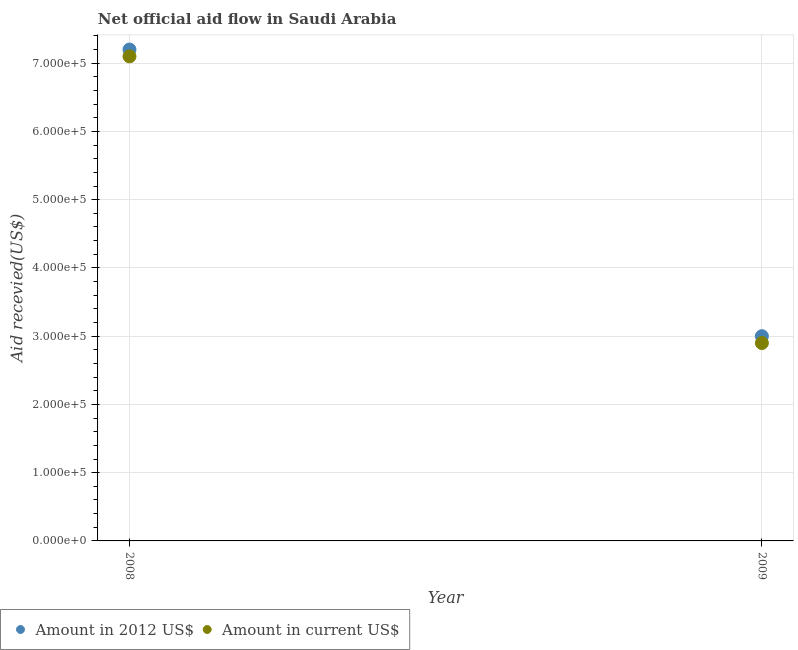Is the number of dotlines equal to the number of legend labels?
Your response must be concise. Yes. What is the amount of aid received(expressed in 2012 us$) in 2008?
Your response must be concise. 7.20e+05. Across all years, what is the maximum amount of aid received(expressed in 2012 us$)?
Ensure brevity in your answer.  7.20e+05. Across all years, what is the minimum amount of aid received(expressed in us$)?
Your response must be concise. 2.90e+05. In which year was the amount of aid received(expressed in 2012 us$) maximum?
Your response must be concise. 2008. In which year was the amount of aid received(expressed in us$) minimum?
Make the answer very short. 2009. What is the total amount of aid received(expressed in us$) in the graph?
Keep it short and to the point. 1.00e+06. What is the difference between the amount of aid received(expressed in 2012 us$) in 2008 and that in 2009?
Your response must be concise. 4.20e+05. What is the difference between the amount of aid received(expressed in us$) in 2008 and the amount of aid received(expressed in 2012 us$) in 2009?
Keep it short and to the point. 4.10e+05. What is the average amount of aid received(expressed in 2012 us$) per year?
Your answer should be very brief. 5.10e+05. In the year 2008, what is the difference between the amount of aid received(expressed in us$) and amount of aid received(expressed in 2012 us$)?
Your answer should be very brief. -10000. In how many years, is the amount of aid received(expressed in us$) greater than 600000 US$?
Provide a short and direct response. 1. Is the amount of aid received(expressed in 2012 us$) strictly less than the amount of aid received(expressed in us$) over the years?
Provide a short and direct response. No. How many dotlines are there?
Offer a very short reply. 2. Does the graph contain any zero values?
Keep it short and to the point. No. How many legend labels are there?
Provide a succinct answer. 2. What is the title of the graph?
Your answer should be very brief. Net official aid flow in Saudi Arabia. Does "Unregistered firms" appear as one of the legend labels in the graph?
Offer a very short reply. No. What is the label or title of the X-axis?
Ensure brevity in your answer.  Year. What is the label or title of the Y-axis?
Provide a short and direct response. Aid recevied(US$). What is the Aid recevied(US$) of Amount in 2012 US$ in 2008?
Offer a very short reply. 7.20e+05. What is the Aid recevied(US$) in Amount in current US$ in 2008?
Offer a very short reply. 7.10e+05. What is the Aid recevied(US$) in Amount in 2012 US$ in 2009?
Your answer should be very brief. 3.00e+05. Across all years, what is the maximum Aid recevied(US$) of Amount in 2012 US$?
Your response must be concise. 7.20e+05. Across all years, what is the maximum Aid recevied(US$) of Amount in current US$?
Offer a terse response. 7.10e+05. What is the total Aid recevied(US$) in Amount in 2012 US$ in the graph?
Your answer should be very brief. 1.02e+06. What is the difference between the Aid recevied(US$) of Amount in 2012 US$ in 2008 and that in 2009?
Provide a succinct answer. 4.20e+05. What is the difference between the Aid recevied(US$) in Amount in 2012 US$ in 2008 and the Aid recevied(US$) in Amount in current US$ in 2009?
Offer a terse response. 4.30e+05. What is the average Aid recevied(US$) of Amount in 2012 US$ per year?
Your answer should be compact. 5.10e+05. In the year 2008, what is the difference between the Aid recevied(US$) of Amount in 2012 US$ and Aid recevied(US$) of Amount in current US$?
Give a very brief answer. 10000. In the year 2009, what is the difference between the Aid recevied(US$) of Amount in 2012 US$ and Aid recevied(US$) of Amount in current US$?
Ensure brevity in your answer.  10000. What is the ratio of the Aid recevied(US$) in Amount in 2012 US$ in 2008 to that in 2009?
Offer a terse response. 2.4. What is the ratio of the Aid recevied(US$) of Amount in current US$ in 2008 to that in 2009?
Make the answer very short. 2.45. What is the difference between the highest and the lowest Aid recevied(US$) of Amount in 2012 US$?
Your answer should be very brief. 4.20e+05. What is the difference between the highest and the lowest Aid recevied(US$) of Amount in current US$?
Give a very brief answer. 4.20e+05. 